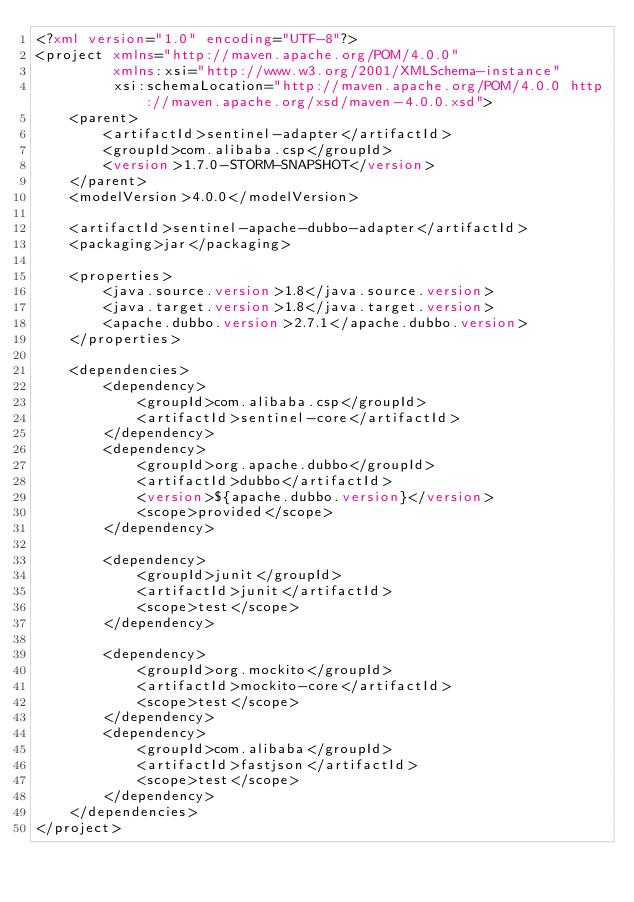<code> <loc_0><loc_0><loc_500><loc_500><_XML_><?xml version="1.0" encoding="UTF-8"?>
<project xmlns="http://maven.apache.org/POM/4.0.0"
         xmlns:xsi="http://www.w3.org/2001/XMLSchema-instance"
         xsi:schemaLocation="http://maven.apache.org/POM/4.0.0 http://maven.apache.org/xsd/maven-4.0.0.xsd">
    <parent>
        <artifactId>sentinel-adapter</artifactId>
        <groupId>com.alibaba.csp</groupId>
        <version>1.7.0-STORM-SNAPSHOT</version>
    </parent>
    <modelVersion>4.0.0</modelVersion>

    <artifactId>sentinel-apache-dubbo-adapter</artifactId>
    <packaging>jar</packaging>

    <properties>
        <java.source.version>1.8</java.source.version>
        <java.target.version>1.8</java.target.version>
        <apache.dubbo.version>2.7.1</apache.dubbo.version>
    </properties>

    <dependencies>
        <dependency>
            <groupId>com.alibaba.csp</groupId>
            <artifactId>sentinel-core</artifactId>
        </dependency>
        <dependency>
            <groupId>org.apache.dubbo</groupId>
            <artifactId>dubbo</artifactId>
            <version>${apache.dubbo.version}</version>
            <scope>provided</scope>
        </dependency>

        <dependency>
            <groupId>junit</groupId>
            <artifactId>junit</artifactId>
            <scope>test</scope>
        </dependency>

        <dependency>
            <groupId>org.mockito</groupId>
            <artifactId>mockito-core</artifactId>
            <scope>test</scope>
        </dependency>
        <dependency>
            <groupId>com.alibaba</groupId>
            <artifactId>fastjson</artifactId>
            <scope>test</scope>
        </dependency>
    </dependencies>
</project></code> 